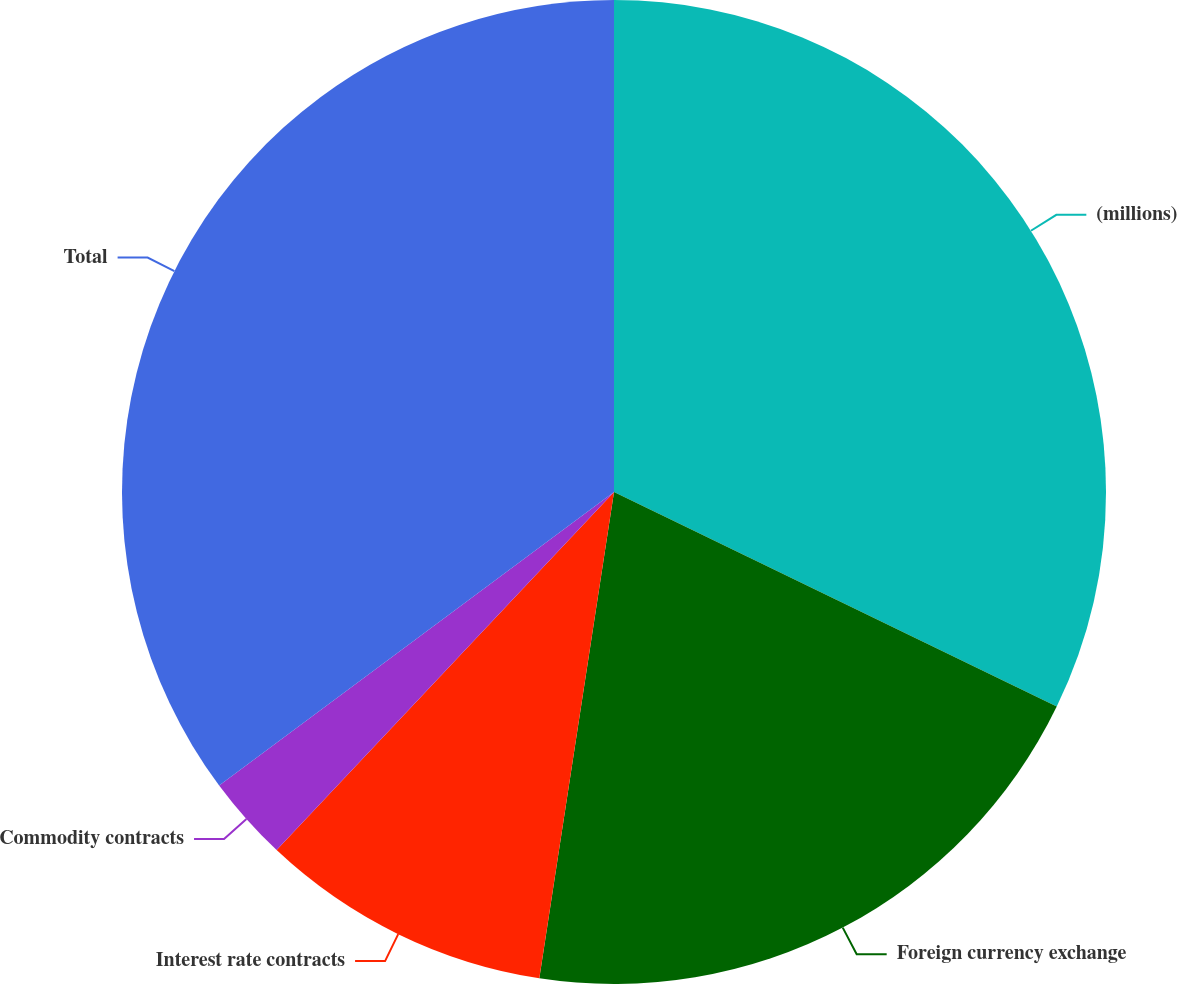Convert chart. <chart><loc_0><loc_0><loc_500><loc_500><pie_chart><fcel>(millions)<fcel>Foreign currency exchange<fcel>Interest rate contracts<fcel>Commodity contracts<fcel>Total<nl><fcel>32.18%<fcel>20.24%<fcel>9.6%<fcel>2.8%<fcel>35.17%<nl></chart> 